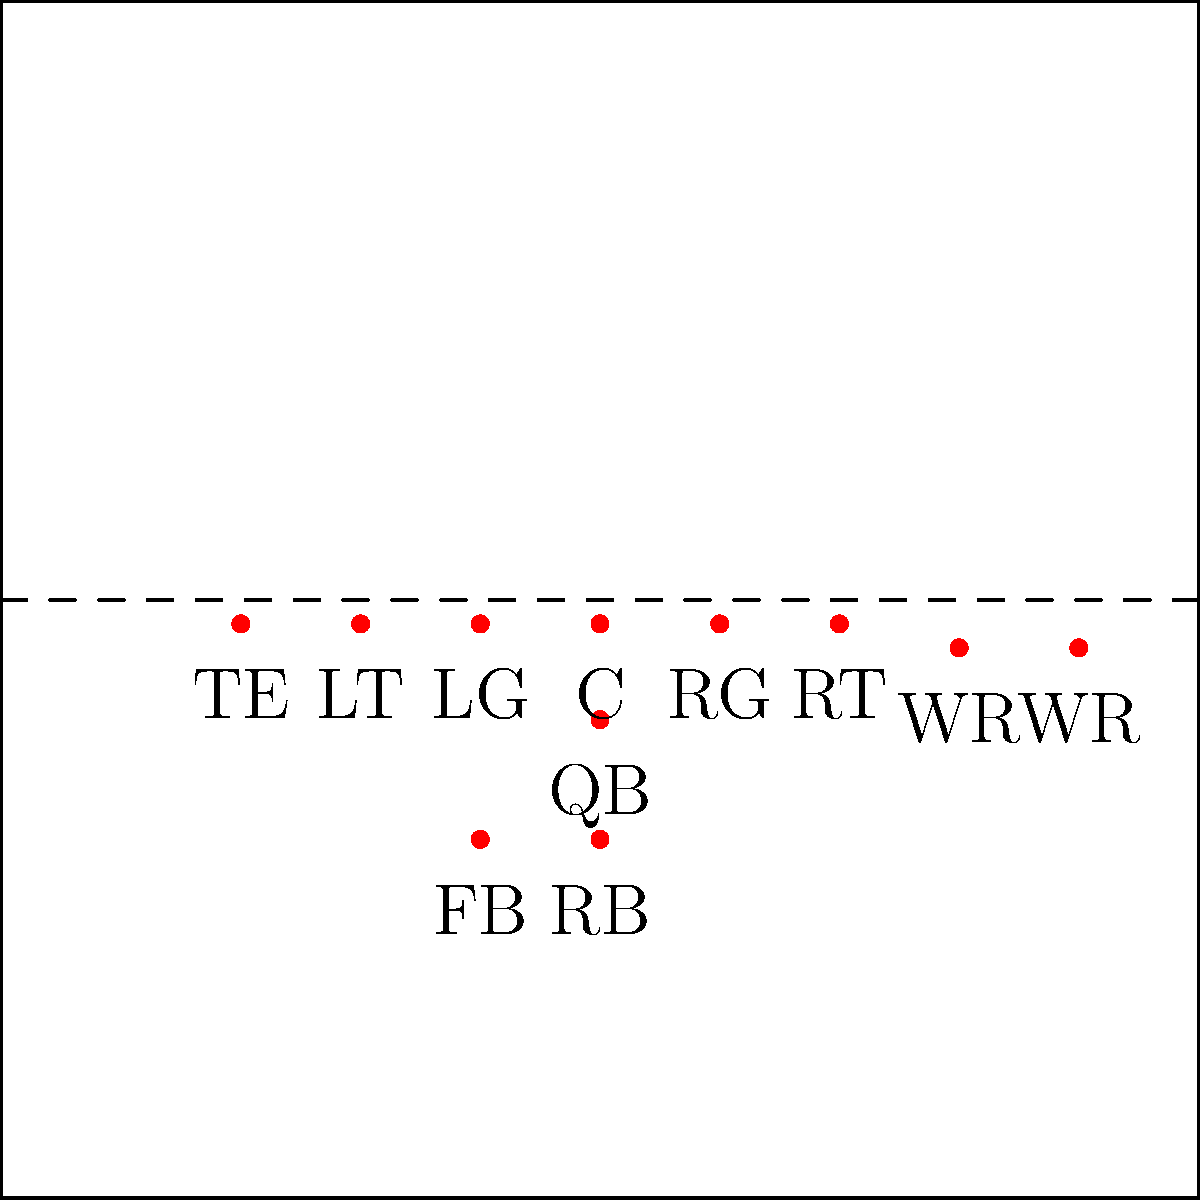Based on the pre-snap offensive formation shown, which type of offensive set is this most likely to be, and what potential play might the offense be setting up for? To identify the offensive formation and potential play, let's analyze the pre-snap positions step-by-step:

1. Line formation:
   - 5 linemen (LT, LG, C, RG, RT) in standard positions
   - 1 tight end (TE) on the left side

2. Backfield:
   - Quarterback (QB) under center
   - Fullback (FB) and Running Back (RB) in I-formation behind the QB

3. Receivers:
   - 2 wide receivers (WR) split out wide on both sides

4. Formation identification:
   - This is an "I-Formation" with a tight end and two wide receivers
   - Also known as "21 personnel" (2 backs, 1 tight end)

5. Potential play analysis:
   - The I-Formation is versatile but often used for power running plays
   - The presence of a fullback suggests a strong run possibility
   - Having a tight end provides extra blocking support for runs or play-action passes
   - Two wide receivers allow for passing options or to spread the defense

6. Most likely play setup:
   - Power run to either side, utilizing the fullback as a lead blocker
   - Play-action pass, using the run formation to set up a deep pass to one of the wide receivers

Given the formation's strength in the run game and Sam Houston State's historically strong running attack, this setup is likely designed for a power run play with the option to audible to a play-action pass if the defense overcommits to stopping the run.
Answer: I-Formation; Power run or play-action pass 